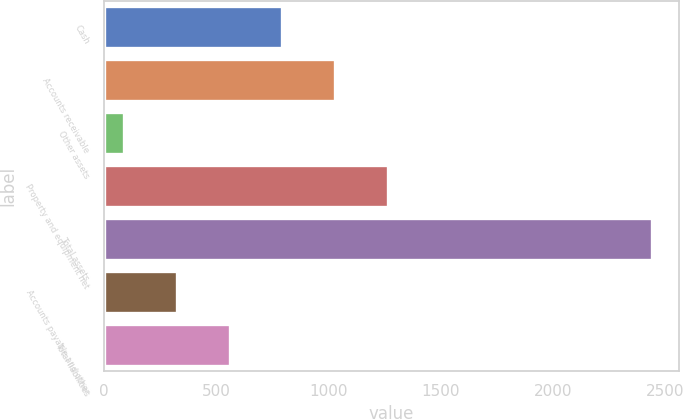Convert chart to OTSL. <chart><loc_0><loc_0><loc_500><loc_500><bar_chart><fcel>Cash<fcel>Accounts receivable<fcel>Other assets<fcel>Property and equipment net<fcel>Total assets<fcel>Accounts payable and other<fcel>Total liabilities<nl><fcel>795.3<fcel>1030.4<fcel>90<fcel>1265.5<fcel>2441<fcel>325.1<fcel>560.2<nl></chart> 